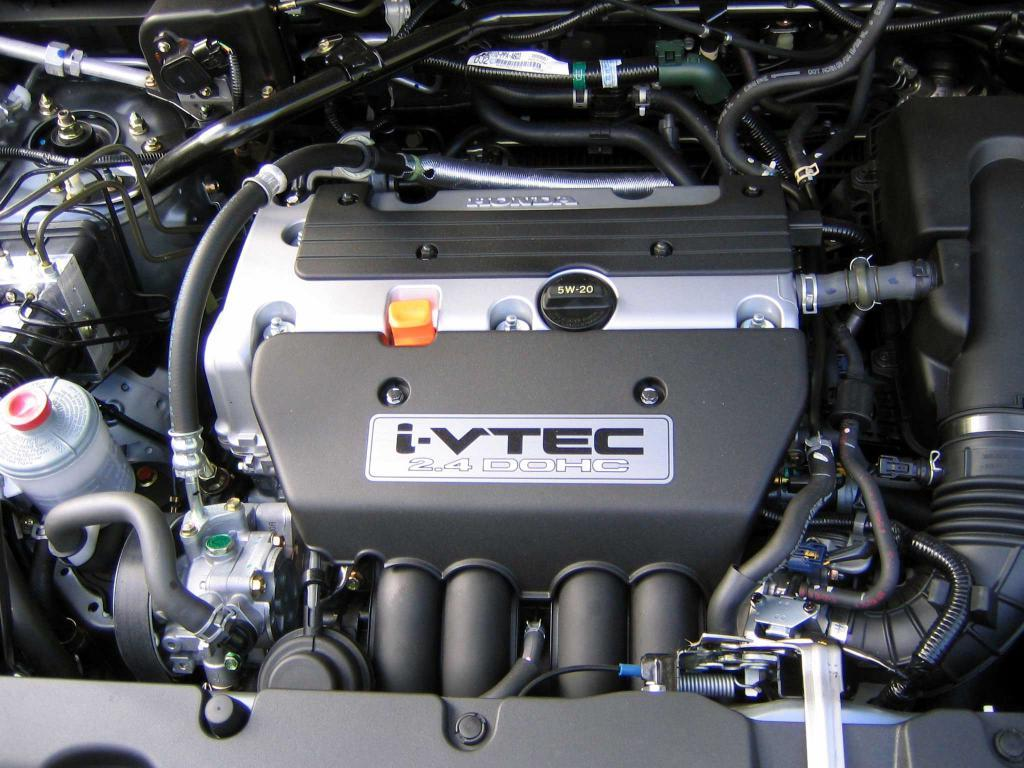What is the main subject of the image? The main subject of the image is an engine of a vehicle. Can you describe the engine in the image? There are many parts connected to the engine in the image. What type of book is placed on the engine in the image? There is no book present in the image; it features an engine with many connected parts. 